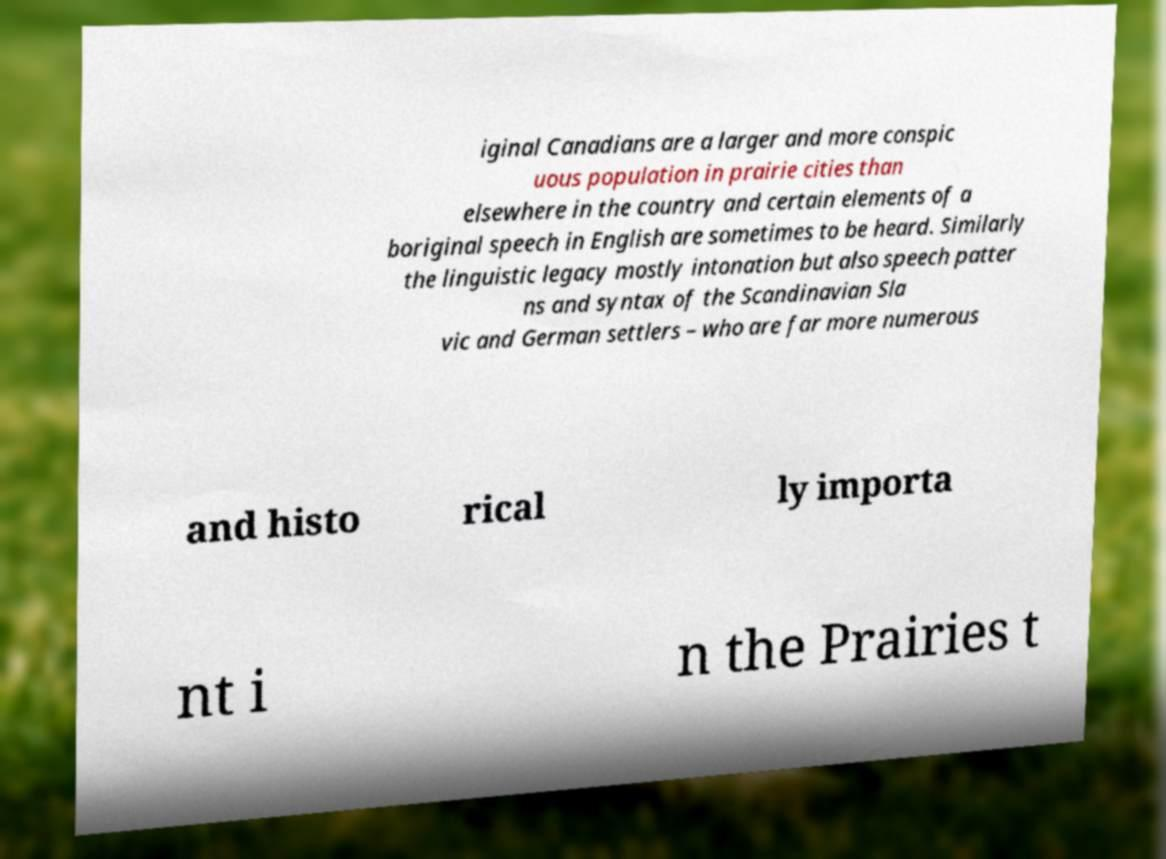For documentation purposes, I need the text within this image transcribed. Could you provide that? iginal Canadians are a larger and more conspic uous population in prairie cities than elsewhere in the country and certain elements of a boriginal speech in English are sometimes to be heard. Similarly the linguistic legacy mostly intonation but also speech patter ns and syntax of the Scandinavian Sla vic and German settlers – who are far more numerous and histo rical ly importa nt i n the Prairies t 